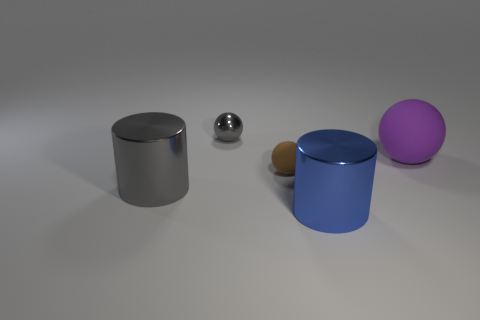Are there any other things that have the same shape as the purple matte object?
Provide a short and direct response. Yes. Is the number of shiny spheres on the right side of the blue metallic thing greater than the number of big metal things right of the big gray object?
Provide a succinct answer. No. How big is the cylinder that is on the right side of the large shiny object that is behind the metallic object that is in front of the large gray cylinder?
Give a very brief answer. Large. Do the blue object and the small thing that is behind the tiny brown ball have the same material?
Offer a terse response. Yes. Do the tiny brown rubber object and the small gray thing have the same shape?
Give a very brief answer. Yes. How many other objects are there of the same material as the blue object?
Give a very brief answer. 2. What number of blue metallic things are the same shape as the small brown matte thing?
Provide a succinct answer. 0. What color is the large thing that is both left of the large ball and right of the gray shiny cylinder?
Your response must be concise. Blue. What number of big gray cylinders are there?
Give a very brief answer. 1. Do the brown sphere and the gray shiny sphere have the same size?
Your answer should be compact. Yes. 